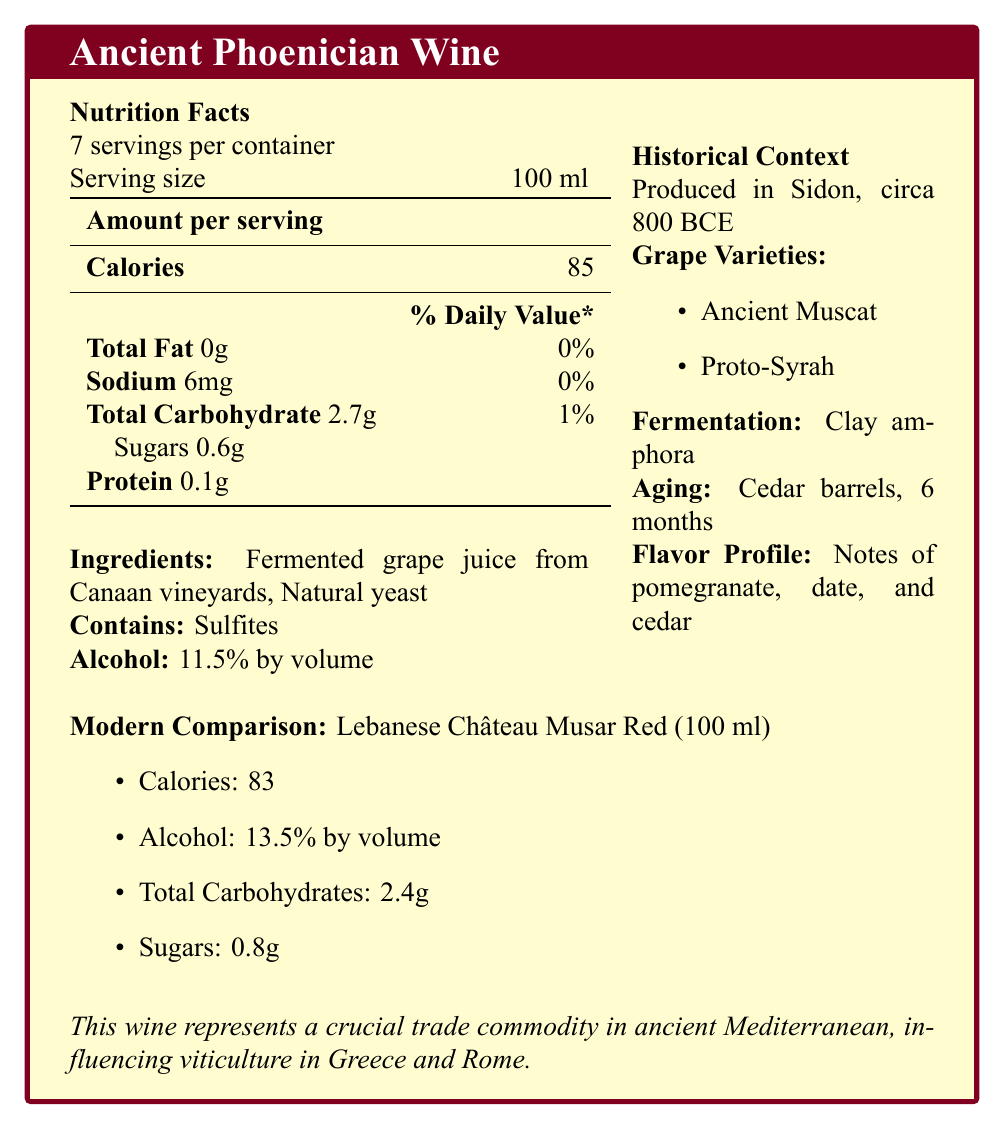what is the serving size of Ancient Phoenician Wine? The serving size is explicitly mentioned in the document as 100 ml.
Answer: 100 ml how many calories are there per serving of Ancient Phoenician Wine? The document lists the caloric content per serving as 85 calories.
Answer: 85 what are the primary ingredients in Ancient Phoenician Wine? The primary ingredients are enumerated in the document.
Answer: Fermented grape juice from Canaan vineyards and Natural yeast how much alcohol is in the Ancient Phoenician Wine by volume? The document specifically states that the alcohol content is 11.5% by volume.
Answer: 11.5% what allergens does the Ancient Phoenician Wine contain? The document mentions that the wine contains sulfites.
Answer: Sulfites which grape varieties are used in Ancient Phoenician Wine? A. Modern Muscat B. Proto-Syrah C. Cabernet Sauvignon D. Ancient Muscat The document lists the grape varieties employed as Ancient Muscat and Proto-Syrah.
Answer: B, D how does the alcohol content of the Ancient Phoenician Wine compare to the modern Lebanese Château Musar Red? A. Higher B. Lower C. The same The alcohol content of Ancient Phoenician Wine is 11.5%, whereas the modern Lebanese Château Musar Red has an alcohol content of 13.5%, indicating the former is lower.
Answer: B does the Ancient Phoenician Wine contain sugars? The document reveals that the wine contains 0.6g of sugars per serving.
Answer: Yes did Ancient Phoenician Wine include tree resins for preservation? It is mentioned that tree resins were used for stability during sea voyages.
Answer: Yes describe the main idea of the document. The document includes facts like nutritional content, grape varieties, fermentation and aging methods, and historical and cultural significance, along with a comparison to a modern Mediterranean wine.
Answer: This document provides nutritional and historical information about Ancient Phoenician Wine, comparing it to a modern wine variety. can the specific age of Sidon’s ancient vineyards be determined from the document? The document states that the wine was produced in Sidon around 800 BCE but provides no detailed information about the age of the vineyards specifically.
Answer: Not enough information 